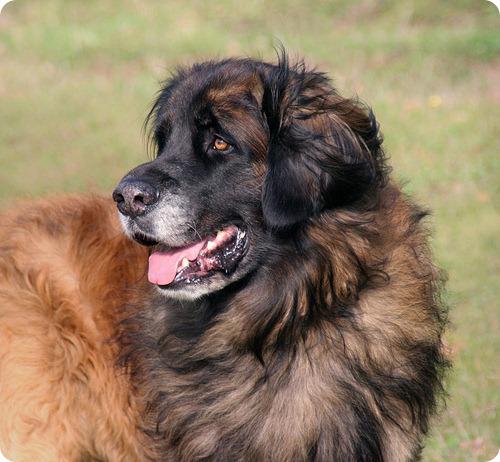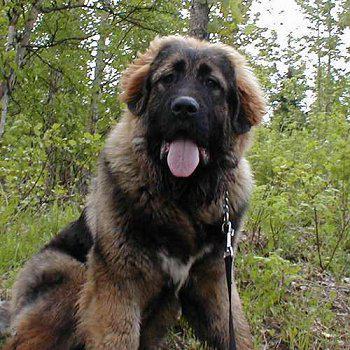The first image is the image on the left, the second image is the image on the right. For the images displayed, is the sentence "In one image, a kneeling woman's head is nearly even with that of the large dog she poses next to." factually correct? Answer yes or no. No. The first image is the image on the left, the second image is the image on the right. Examine the images to the left and right. Is the description "The left image includes a human interacting with a large dog." accurate? Answer yes or no. No. 